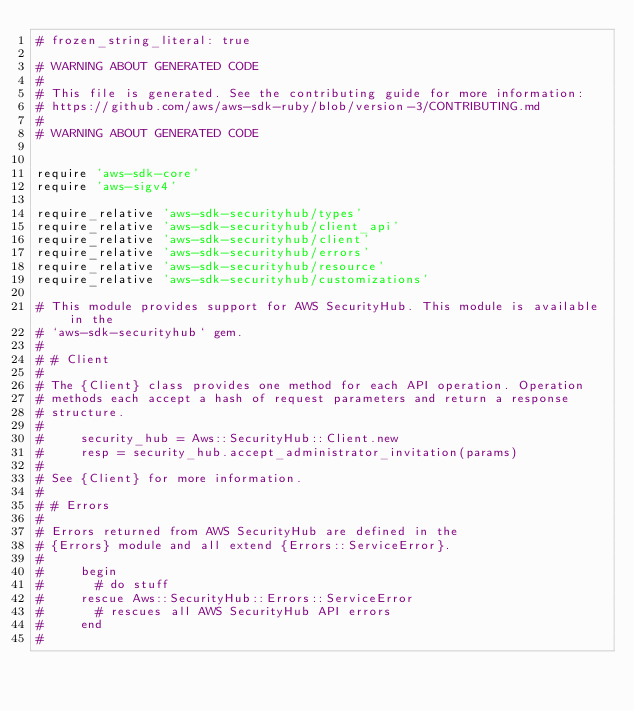Convert code to text. <code><loc_0><loc_0><loc_500><loc_500><_Ruby_># frozen_string_literal: true

# WARNING ABOUT GENERATED CODE
#
# This file is generated. See the contributing guide for more information:
# https://github.com/aws/aws-sdk-ruby/blob/version-3/CONTRIBUTING.md
#
# WARNING ABOUT GENERATED CODE


require 'aws-sdk-core'
require 'aws-sigv4'

require_relative 'aws-sdk-securityhub/types'
require_relative 'aws-sdk-securityhub/client_api'
require_relative 'aws-sdk-securityhub/client'
require_relative 'aws-sdk-securityhub/errors'
require_relative 'aws-sdk-securityhub/resource'
require_relative 'aws-sdk-securityhub/customizations'

# This module provides support for AWS SecurityHub. This module is available in the
# `aws-sdk-securityhub` gem.
#
# # Client
#
# The {Client} class provides one method for each API operation. Operation
# methods each accept a hash of request parameters and return a response
# structure.
#
#     security_hub = Aws::SecurityHub::Client.new
#     resp = security_hub.accept_administrator_invitation(params)
#
# See {Client} for more information.
#
# # Errors
#
# Errors returned from AWS SecurityHub are defined in the
# {Errors} module and all extend {Errors::ServiceError}.
#
#     begin
#       # do stuff
#     rescue Aws::SecurityHub::Errors::ServiceError
#       # rescues all AWS SecurityHub API errors
#     end
#</code> 